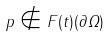Convert formula to latex. <formula><loc_0><loc_0><loc_500><loc_500>p \notin F ( t ) ( \partial \Omega )</formula> 